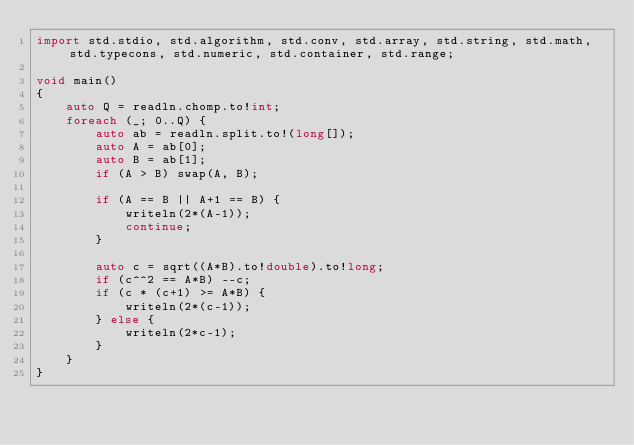Convert code to text. <code><loc_0><loc_0><loc_500><loc_500><_D_>import std.stdio, std.algorithm, std.conv, std.array, std.string, std.math, std.typecons, std.numeric, std.container, std.range;

void main()
{
    auto Q = readln.chomp.to!int;
    foreach (_; 0..Q) {
        auto ab = readln.split.to!(long[]);
        auto A = ab[0];
        auto B = ab[1];
        if (A > B) swap(A, B);

        if (A == B || A+1 == B) {
            writeln(2*(A-1));
            continue;
        }

        auto c = sqrt((A*B).to!double).to!long;
        if (c^^2 == A*B) --c;
        if (c * (c+1) >= A*B) {
            writeln(2*(c-1));
        } else {
            writeln(2*c-1);
        }
    }
}</code> 